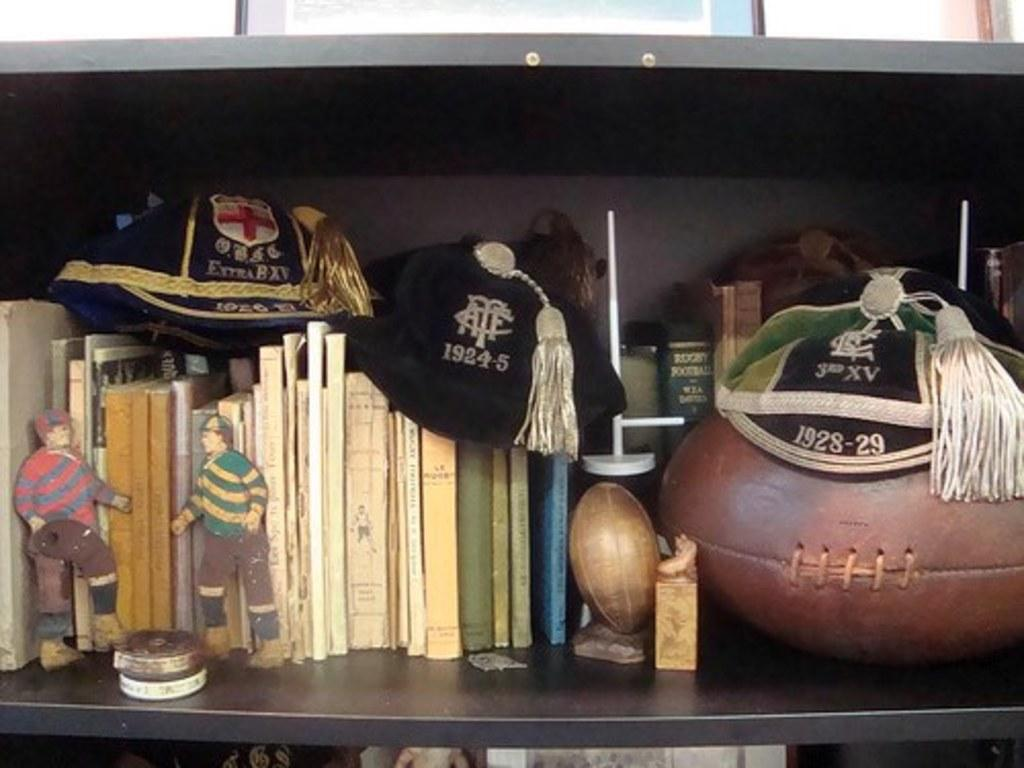What can be seen on the shelf in the image? There are books, a rugby ball, and caps visible on the shelf in the image. What other objects are present on the shelf? There are other objects inside the shelf, but their specific details are not mentioned in the provided facts. What type of pin can be seen holding the caps together in the image? There is no pin visible in the image; the caps are not shown as being held together by any pin. 